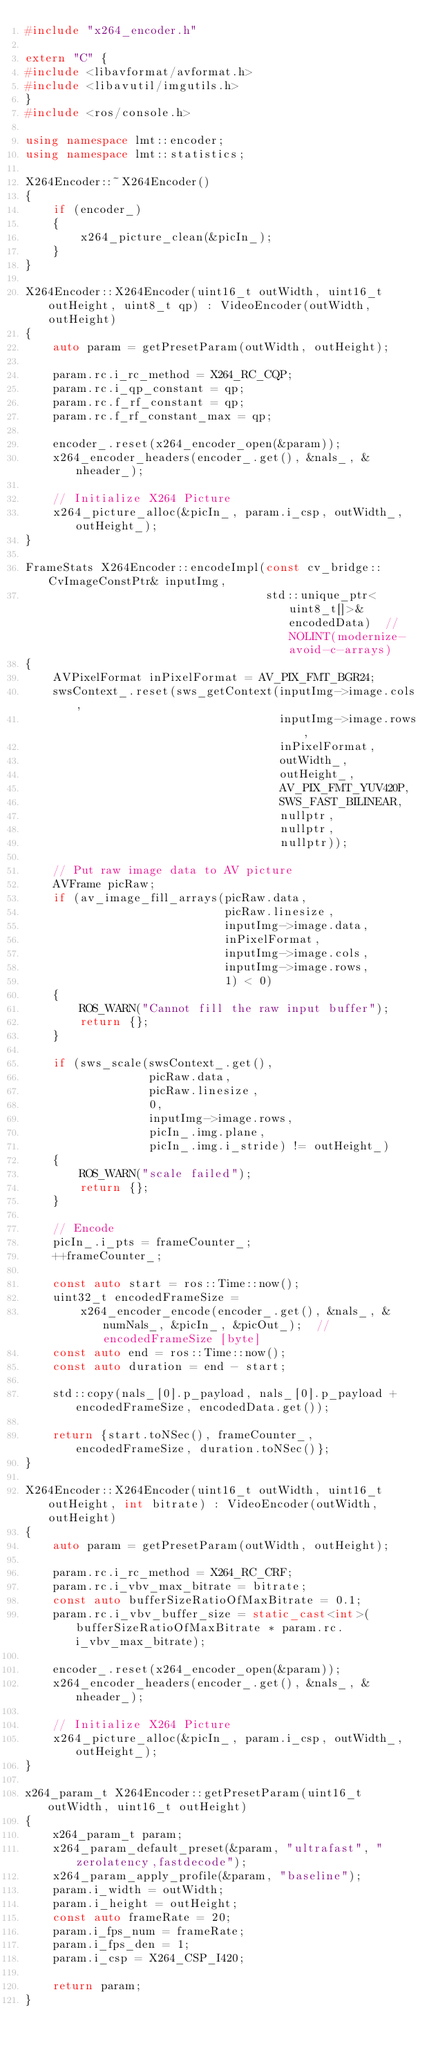Convert code to text. <code><loc_0><loc_0><loc_500><loc_500><_C++_>#include "x264_encoder.h"

extern "C" {
#include <libavformat/avformat.h>
#include <libavutil/imgutils.h>
}
#include <ros/console.h>

using namespace lmt::encoder;
using namespace lmt::statistics;

X264Encoder::~X264Encoder()
{
    if (encoder_)
    {
        x264_picture_clean(&picIn_);
    }
}

X264Encoder::X264Encoder(uint16_t outWidth, uint16_t outHeight, uint8_t qp) : VideoEncoder(outWidth, outHeight)
{
    auto param = getPresetParam(outWidth, outHeight);

    param.rc.i_rc_method = X264_RC_CQP;
    param.rc.i_qp_constant = qp;
    param.rc.f_rf_constant = qp;
    param.rc.f_rf_constant_max = qp;

    encoder_.reset(x264_encoder_open(&param));
    x264_encoder_headers(encoder_.get(), &nals_, &nheader_);

    // Initialize X264 Picture
    x264_picture_alloc(&picIn_, param.i_csp, outWidth_, outHeight_);
}

FrameStats X264Encoder::encodeImpl(const cv_bridge::CvImageConstPtr& inputImg,
                                   std::unique_ptr<uint8_t[]>& encodedData)  // NOLINT(modernize-avoid-c-arrays)
{
    AVPixelFormat inPixelFormat = AV_PIX_FMT_BGR24;
    swsContext_.reset(sws_getContext(inputImg->image.cols,
                                     inputImg->image.rows,
                                     inPixelFormat,
                                     outWidth_,
                                     outHeight_,
                                     AV_PIX_FMT_YUV420P,
                                     SWS_FAST_BILINEAR,
                                     nullptr,
                                     nullptr,
                                     nullptr));

    // Put raw image data to AV picture
    AVFrame picRaw;
    if (av_image_fill_arrays(picRaw.data,
                             picRaw.linesize,
                             inputImg->image.data,
                             inPixelFormat,
                             inputImg->image.cols,
                             inputImg->image.rows,
                             1) < 0)
    {
        ROS_WARN("Cannot fill the raw input buffer");
        return {};
    }

    if (sws_scale(swsContext_.get(),
                  picRaw.data,
                  picRaw.linesize,
                  0,
                  inputImg->image.rows,
                  picIn_.img.plane,
                  picIn_.img.i_stride) != outHeight_)
    {
        ROS_WARN("scale failed");
        return {};
    }

    // Encode
    picIn_.i_pts = frameCounter_;
    ++frameCounter_;

    const auto start = ros::Time::now();
    uint32_t encodedFrameSize =
        x264_encoder_encode(encoder_.get(), &nals_, &numNals_, &picIn_, &picOut_);  // encodedFrameSize [byte]
    const auto end = ros::Time::now();
    const auto duration = end - start;

    std::copy(nals_[0].p_payload, nals_[0].p_payload + encodedFrameSize, encodedData.get());

    return {start.toNSec(), frameCounter_, encodedFrameSize, duration.toNSec()};
}

X264Encoder::X264Encoder(uint16_t outWidth, uint16_t outHeight, int bitrate) : VideoEncoder(outWidth, outHeight)
{
    auto param = getPresetParam(outWidth, outHeight);

    param.rc.i_rc_method = X264_RC_CRF;
    param.rc.i_vbv_max_bitrate = bitrate;
    const auto bufferSizeRatioOfMaxBitrate = 0.1;
    param.rc.i_vbv_buffer_size = static_cast<int>(bufferSizeRatioOfMaxBitrate * param.rc.i_vbv_max_bitrate);

    encoder_.reset(x264_encoder_open(&param));
    x264_encoder_headers(encoder_.get(), &nals_, &nheader_);

    // Initialize X264 Picture
    x264_picture_alloc(&picIn_, param.i_csp, outWidth_, outHeight_);
}

x264_param_t X264Encoder::getPresetParam(uint16_t outWidth, uint16_t outHeight)
{
    x264_param_t param;
    x264_param_default_preset(&param, "ultrafast", "zerolatency,fastdecode");
    x264_param_apply_profile(&param, "baseline");
    param.i_width = outWidth;
    param.i_height = outHeight;
    const auto frameRate = 20;
    param.i_fps_num = frameRate;
    param.i_fps_den = 1;
    param.i_csp = X264_CSP_I420;

    return param;
}
</code> 